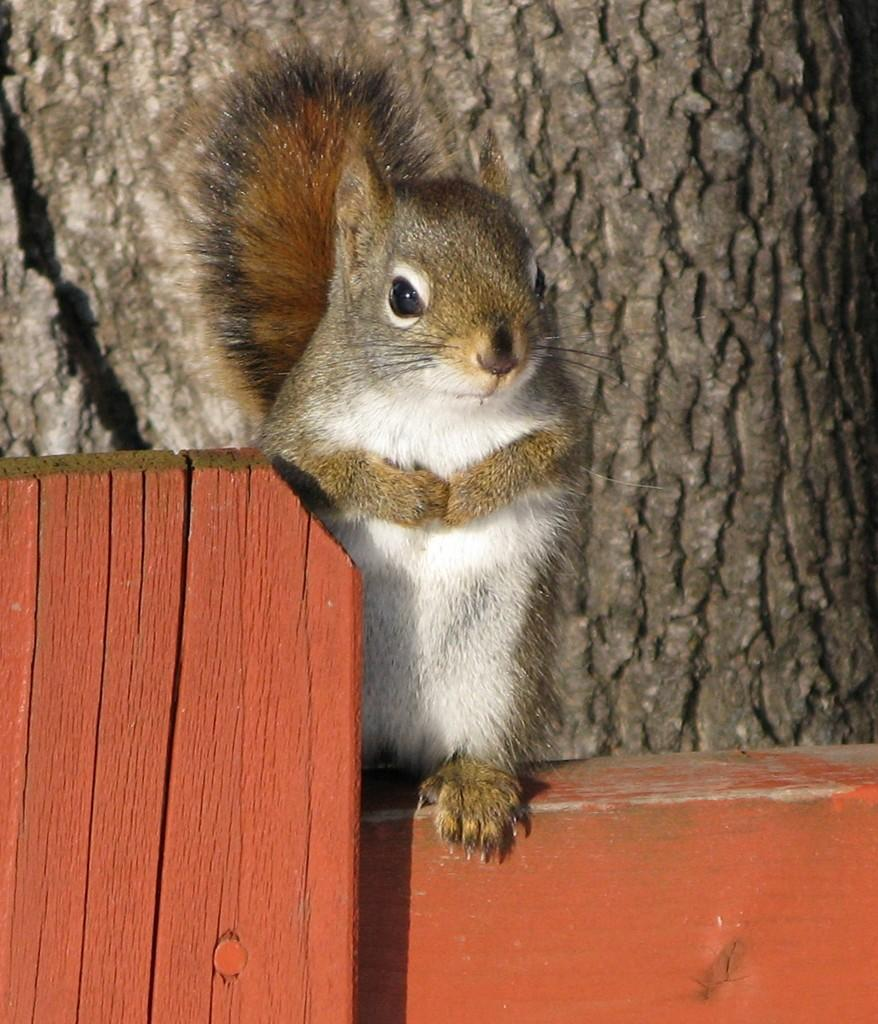What animal is in the middle of the image? There is a squirrel in the middle of the image. What can be seen in the background of the image? There is a tree trunk in the background of the image. What type of vest is the visitor wearing in the image? There is no visitor or vest present in the image; it only features a squirrel and a tree trunk. 